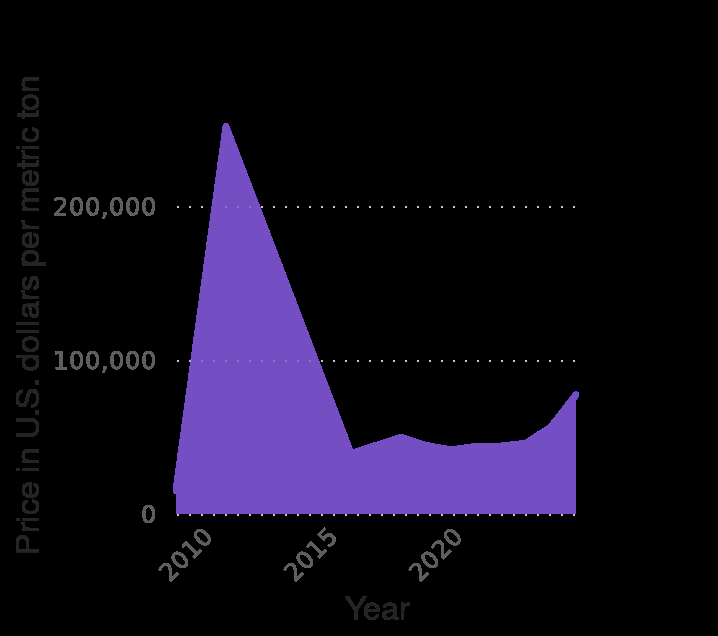<image>
What is the type of diagram used to represent the neodymium oxide price worldwide from 2009 to 2025?  The neodymium oxide price worldwide from 2009 to 2025 is represented using an area diagram. When did the Neodymium oxide price reach its peak?  The Neodymium oxide price reached its peak around the year 2011. When was the lowest price of Neodymium oxide recorded?  The lowest price of Neodymium oxide was recorded in 2016. 